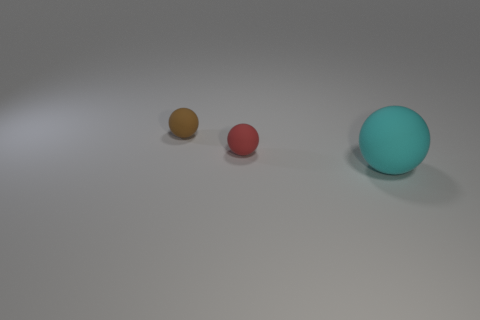Subtract all tiny red spheres. How many spheres are left? 2 Add 1 big cyan rubber objects. How many objects exist? 4 Subtract all brown spheres. How many spheres are left? 2 Subtract all red cubes. How many cyan balls are left? 1 Subtract all cyan matte balls. Subtract all large cyan matte spheres. How many objects are left? 1 Add 3 large cyan rubber things. How many large cyan rubber things are left? 4 Add 1 big green balls. How many big green balls exist? 1 Subtract 0 purple balls. How many objects are left? 3 Subtract all gray balls. Subtract all yellow cubes. How many balls are left? 3 